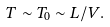Convert formula to latex. <formula><loc_0><loc_0><loc_500><loc_500>T \sim T _ { 0 } \sim L / V .</formula> 